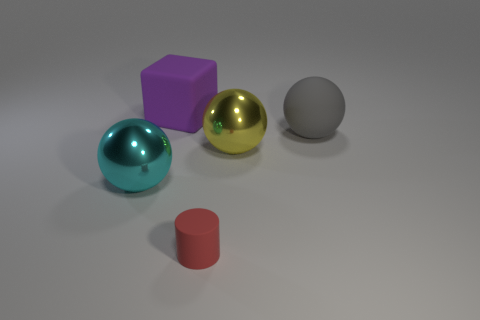Can you describe the composition of the objects in relation to each other? Certainly, in this image, we see an array of geometric shapes arranged in a linear narrative from left to right. A cyan sphere leads the eye toward a purple cube, followed by a golden sphere, and concluding with a larger grey sphere. In the foreground, slightly offset from this line, sits a small red cylinder. The arrangement feels deliberate, inviting an exploration of form, color, and size contrast. 